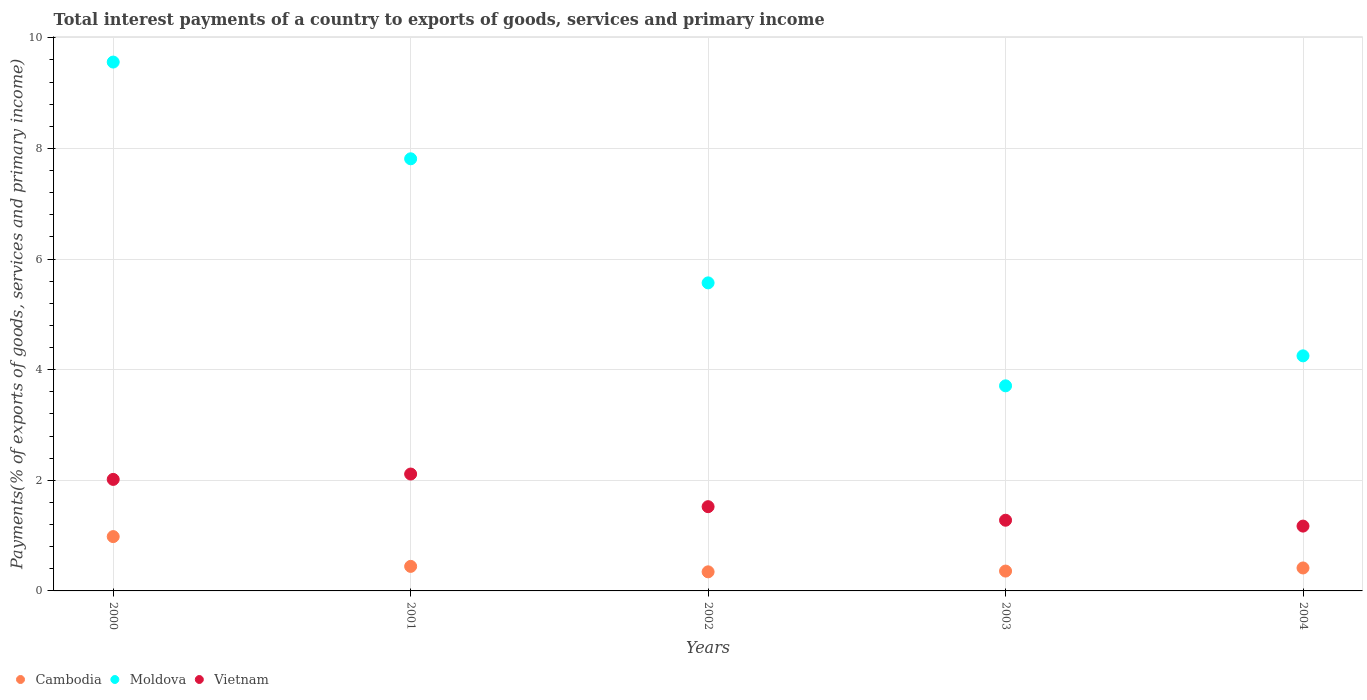What is the total interest payments in Moldova in 2001?
Ensure brevity in your answer.  7.81. Across all years, what is the maximum total interest payments in Cambodia?
Provide a succinct answer. 0.98. Across all years, what is the minimum total interest payments in Moldova?
Provide a short and direct response. 3.71. In which year was the total interest payments in Vietnam maximum?
Provide a short and direct response. 2001. In which year was the total interest payments in Moldova minimum?
Offer a very short reply. 2003. What is the total total interest payments in Vietnam in the graph?
Your answer should be compact. 8.1. What is the difference between the total interest payments in Vietnam in 2003 and that in 2004?
Give a very brief answer. 0.11. What is the difference between the total interest payments in Cambodia in 2002 and the total interest payments in Vietnam in 2001?
Keep it short and to the point. -1.77. What is the average total interest payments in Vietnam per year?
Ensure brevity in your answer.  1.62. In the year 2001, what is the difference between the total interest payments in Moldova and total interest payments in Vietnam?
Your response must be concise. 5.7. In how many years, is the total interest payments in Vietnam greater than 6.8 %?
Your answer should be very brief. 0. What is the ratio of the total interest payments in Cambodia in 2002 to that in 2003?
Offer a terse response. 0.96. What is the difference between the highest and the second highest total interest payments in Vietnam?
Provide a succinct answer. 0.1. What is the difference between the highest and the lowest total interest payments in Vietnam?
Make the answer very short. 0.94. In how many years, is the total interest payments in Moldova greater than the average total interest payments in Moldova taken over all years?
Ensure brevity in your answer.  2. Does the total interest payments in Cambodia monotonically increase over the years?
Your response must be concise. No. Is the total interest payments in Cambodia strictly greater than the total interest payments in Moldova over the years?
Offer a very short reply. No. What is the difference between two consecutive major ticks on the Y-axis?
Offer a very short reply. 2. Are the values on the major ticks of Y-axis written in scientific E-notation?
Ensure brevity in your answer.  No. Does the graph contain any zero values?
Ensure brevity in your answer.  No. Does the graph contain grids?
Provide a short and direct response. Yes. Where does the legend appear in the graph?
Offer a terse response. Bottom left. How many legend labels are there?
Offer a terse response. 3. What is the title of the graph?
Provide a short and direct response. Total interest payments of a country to exports of goods, services and primary income. Does "Thailand" appear as one of the legend labels in the graph?
Offer a terse response. No. What is the label or title of the X-axis?
Ensure brevity in your answer.  Years. What is the label or title of the Y-axis?
Offer a very short reply. Payments(% of exports of goods, services and primary income). What is the Payments(% of exports of goods, services and primary income) of Cambodia in 2000?
Your answer should be compact. 0.98. What is the Payments(% of exports of goods, services and primary income) in Moldova in 2000?
Offer a very short reply. 9.56. What is the Payments(% of exports of goods, services and primary income) in Vietnam in 2000?
Give a very brief answer. 2.02. What is the Payments(% of exports of goods, services and primary income) of Cambodia in 2001?
Provide a short and direct response. 0.44. What is the Payments(% of exports of goods, services and primary income) in Moldova in 2001?
Your answer should be very brief. 7.81. What is the Payments(% of exports of goods, services and primary income) in Vietnam in 2001?
Offer a terse response. 2.11. What is the Payments(% of exports of goods, services and primary income) of Cambodia in 2002?
Provide a short and direct response. 0.35. What is the Payments(% of exports of goods, services and primary income) in Moldova in 2002?
Offer a very short reply. 5.57. What is the Payments(% of exports of goods, services and primary income) in Vietnam in 2002?
Ensure brevity in your answer.  1.52. What is the Payments(% of exports of goods, services and primary income) in Cambodia in 2003?
Give a very brief answer. 0.36. What is the Payments(% of exports of goods, services and primary income) of Moldova in 2003?
Provide a succinct answer. 3.71. What is the Payments(% of exports of goods, services and primary income) in Vietnam in 2003?
Provide a succinct answer. 1.28. What is the Payments(% of exports of goods, services and primary income) in Cambodia in 2004?
Your answer should be very brief. 0.42. What is the Payments(% of exports of goods, services and primary income) of Moldova in 2004?
Your answer should be very brief. 4.25. What is the Payments(% of exports of goods, services and primary income) in Vietnam in 2004?
Your answer should be very brief. 1.17. Across all years, what is the maximum Payments(% of exports of goods, services and primary income) in Cambodia?
Ensure brevity in your answer.  0.98. Across all years, what is the maximum Payments(% of exports of goods, services and primary income) in Moldova?
Provide a short and direct response. 9.56. Across all years, what is the maximum Payments(% of exports of goods, services and primary income) in Vietnam?
Provide a succinct answer. 2.11. Across all years, what is the minimum Payments(% of exports of goods, services and primary income) of Cambodia?
Your answer should be very brief. 0.35. Across all years, what is the minimum Payments(% of exports of goods, services and primary income) in Moldova?
Make the answer very short. 3.71. Across all years, what is the minimum Payments(% of exports of goods, services and primary income) of Vietnam?
Offer a terse response. 1.17. What is the total Payments(% of exports of goods, services and primary income) in Cambodia in the graph?
Your answer should be compact. 2.55. What is the total Payments(% of exports of goods, services and primary income) of Moldova in the graph?
Provide a short and direct response. 30.9. What is the total Payments(% of exports of goods, services and primary income) in Vietnam in the graph?
Make the answer very short. 8.1. What is the difference between the Payments(% of exports of goods, services and primary income) of Cambodia in 2000 and that in 2001?
Provide a short and direct response. 0.54. What is the difference between the Payments(% of exports of goods, services and primary income) of Moldova in 2000 and that in 2001?
Give a very brief answer. 1.75. What is the difference between the Payments(% of exports of goods, services and primary income) of Vietnam in 2000 and that in 2001?
Provide a short and direct response. -0.1. What is the difference between the Payments(% of exports of goods, services and primary income) of Cambodia in 2000 and that in 2002?
Provide a short and direct response. 0.64. What is the difference between the Payments(% of exports of goods, services and primary income) of Moldova in 2000 and that in 2002?
Offer a very short reply. 3.99. What is the difference between the Payments(% of exports of goods, services and primary income) of Vietnam in 2000 and that in 2002?
Your answer should be compact. 0.49. What is the difference between the Payments(% of exports of goods, services and primary income) in Cambodia in 2000 and that in 2003?
Provide a succinct answer. 0.62. What is the difference between the Payments(% of exports of goods, services and primary income) in Moldova in 2000 and that in 2003?
Offer a terse response. 5.85. What is the difference between the Payments(% of exports of goods, services and primary income) in Vietnam in 2000 and that in 2003?
Offer a very short reply. 0.74. What is the difference between the Payments(% of exports of goods, services and primary income) of Cambodia in 2000 and that in 2004?
Offer a terse response. 0.57. What is the difference between the Payments(% of exports of goods, services and primary income) in Moldova in 2000 and that in 2004?
Make the answer very short. 5.31. What is the difference between the Payments(% of exports of goods, services and primary income) of Vietnam in 2000 and that in 2004?
Offer a very short reply. 0.84. What is the difference between the Payments(% of exports of goods, services and primary income) of Cambodia in 2001 and that in 2002?
Make the answer very short. 0.1. What is the difference between the Payments(% of exports of goods, services and primary income) in Moldova in 2001 and that in 2002?
Keep it short and to the point. 2.24. What is the difference between the Payments(% of exports of goods, services and primary income) in Vietnam in 2001 and that in 2002?
Keep it short and to the point. 0.59. What is the difference between the Payments(% of exports of goods, services and primary income) of Cambodia in 2001 and that in 2003?
Provide a succinct answer. 0.08. What is the difference between the Payments(% of exports of goods, services and primary income) of Moldova in 2001 and that in 2003?
Keep it short and to the point. 4.11. What is the difference between the Payments(% of exports of goods, services and primary income) of Vietnam in 2001 and that in 2003?
Your answer should be very brief. 0.84. What is the difference between the Payments(% of exports of goods, services and primary income) of Cambodia in 2001 and that in 2004?
Provide a short and direct response. 0.03. What is the difference between the Payments(% of exports of goods, services and primary income) in Moldova in 2001 and that in 2004?
Your answer should be compact. 3.56. What is the difference between the Payments(% of exports of goods, services and primary income) in Vietnam in 2001 and that in 2004?
Your answer should be very brief. 0.94. What is the difference between the Payments(% of exports of goods, services and primary income) of Cambodia in 2002 and that in 2003?
Offer a terse response. -0.01. What is the difference between the Payments(% of exports of goods, services and primary income) in Moldova in 2002 and that in 2003?
Give a very brief answer. 1.86. What is the difference between the Payments(% of exports of goods, services and primary income) of Vietnam in 2002 and that in 2003?
Offer a terse response. 0.25. What is the difference between the Payments(% of exports of goods, services and primary income) of Cambodia in 2002 and that in 2004?
Make the answer very short. -0.07. What is the difference between the Payments(% of exports of goods, services and primary income) in Moldova in 2002 and that in 2004?
Your response must be concise. 1.32. What is the difference between the Payments(% of exports of goods, services and primary income) of Vietnam in 2002 and that in 2004?
Give a very brief answer. 0.35. What is the difference between the Payments(% of exports of goods, services and primary income) of Cambodia in 2003 and that in 2004?
Make the answer very short. -0.06. What is the difference between the Payments(% of exports of goods, services and primary income) in Moldova in 2003 and that in 2004?
Keep it short and to the point. -0.54. What is the difference between the Payments(% of exports of goods, services and primary income) in Vietnam in 2003 and that in 2004?
Your answer should be compact. 0.11. What is the difference between the Payments(% of exports of goods, services and primary income) in Cambodia in 2000 and the Payments(% of exports of goods, services and primary income) in Moldova in 2001?
Your answer should be very brief. -6.83. What is the difference between the Payments(% of exports of goods, services and primary income) of Cambodia in 2000 and the Payments(% of exports of goods, services and primary income) of Vietnam in 2001?
Offer a terse response. -1.13. What is the difference between the Payments(% of exports of goods, services and primary income) in Moldova in 2000 and the Payments(% of exports of goods, services and primary income) in Vietnam in 2001?
Keep it short and to the point. 7.45. What is the difference between the Payments(% of exports of goods, services and primary income) of Cambodia in 2000 and the Payments(% of exports of goods, services and primary income) of Moldova in 2002?
Make the answer very short. -4.59. What is the difference between the Payments(% of exports of goods, services and primary income) in Cambodia in 2000 and the Payments(% of exports of goods, services and primary income) in Vietnam in 2002?
Make the answer very short. -0.54. What is the difference between the Payments(% of exports of goods, services and primary income) of Moldova in 2000 and the Payments(% of exports of goods, services and primary income) of Vietnam in 2002?
Your response must be concise. 8.04. What is the difference between the Payments(% of exports of goods, services and primary income) in Cambodia in 2000 and the Payments(% of exports of goods, services and primary income) in Moldova in 2003?
Give a very brief answer. -2.73. What is the difference between the Payments(% of exports of goods, services and primary income) of Cambodia in 2000 and the Payments(% of exports of goods, services and primary income) of Vietnam in 2003?
Offer a terse response. -0.3. What is the difference between the Payments(% of exports of goods, services and primary income) of Moldova in 2000 and the Payments(% of exports of goods, services and primary income) of Vietnam in 2003?
Give a very brief answer. 8.28. What is the difference between the Payments(% of exports of goods, services and primary income) in Cambodia in 2000 and the Payments(% of exports of goods, services and primary income) in Moldova in 2004?
Keep it short and to the point. -3.27. What is the difference between the Payments(% of exports of goods, services and primary income) of Cambodia in 2000 and the Payments(% of exports of goods, services and primary income) of Vietnam in 2004?
Ensure brevity in your answer.  -0.19. What is the difference between the Payments(% of exports of goods, services and primary income) of Moldova in 2000 and the Payments(% of exports of goods, services and primary income) of Vietnam in 2004?
Your answer should be very brief. 8.39. What is the difference between the Payments(% of exports of goods, services and primary income) in Cambodia in 2001 and the Payments(% of exports of goods, services and primary income) in Moldova in 2002?
Keep it short and to the point. -5.13. What is the difference between the Payments(% of exports of goods, services and primary income) of Cambodia in 2001 and the Payments(% of exports of goods, services and primary income) of Vietnam in 2002?
Make the answer very short. -1.08. What is the difference between the Payments(% of exports of goods, services and primary income) of Moldova in 2001 and the Payments(% of exports of goods, services and primary income) of Vietnam in 2002?
Offer a very short reply. 6.29. What is the difference between the Payments(% of exports of goods, services and primary income) of Cambodia in 2001 and the Payments(% of exports of goods, services and primary income) of Moldova in 2003?
Offer a terse response. -3.26. What is the difference between the Payments(% of exports of goods, services and primary income) of Cambodia in 2001 and the Payments(% of exports of goods, services and primary income) of Vietnam in 2003?
Ensure brevity in your answer.  -0.83. What is the difference between the Payments(% of exports of goods, services and primary income) of Moldova in 2001 and the Payments(% of exports of goods, services and primary income) of Vietnam in 2003?
Provide a succinct answer. 6.54. What is the difference between the Payments(% of exports of goods, services and primary income) in Cambodia in 2001 and the Payments(% of exports of goods, services and primary income) in Moldova in 2004?
Your response must be concise. -3.81. What is the difference between the Payments(% of exports of goods, services and primary income) of Cambodia in 2001 and the Payments(% of exports of goods, services and primary income) of Vietnam in 2004?
Make the answer very short. -0.73. What is the difference between the Payments(% of exports of goods, services and primary income) in Moldova in 2001 and the Payments(% of exports of goods, services and primary income) in Vietnam in 2004?
Provide a short and direct response. 6.64. What is the difference between the Payments(% of exports of goods, services and primary income) of Cambodia in 2002 and the Payments(% of exports of goods, services and primary income) of Moldova in 2003?
Make the answer very short. -3.36. What is the difference between the Payments(% of exports of goods, services and primary income) of Cambodia in 2002 and the Payments(% of exports of goods, services and primary income) of Vietnam in 2003?
Give a very brief answer. -0.93. What is the difference between the Payments(% of exports of goods, services and primary income) of Moldova in 2002 and the Payments(% of exports of goods, services and primary income) of Vietnam in 2003?
Offer a very short reply. 4.29. What is the difference between the Payments(% of exports of goods, services and primary income) in Cambodia in 2002 and the Payments(% of exports of goods, services and primary income) in Moldova in 2004?
Give a very brief answer. -3.91. What is the difference between the Payments(% of exports of goods, services and primary income) of Cambodia in 2002 and the Payments(% of exports of goods, services and primary income) of Vietnam in 2004?
Your answer should be compact. -0.83. What is the difference between the Payments(% of exports of goods, services and primary income) of Moldova in 2002 and the Payments(% of exports of goods, services and primary income) of Vietnam in 2004?
Offer a very short reply. 4.4. What is the difference between the Payments(% of exports of goods, services and primary income) in Cambodia in 2003 and the Payments(% of exports of goods, services and primary income) in Moldova in 2004?
Give a very brief answer. -3.89. What is the difference between the Payments(% of exports of goods, services and primary income) in Cambodia in 2003 and the Payments(% of exports of goods, services and primary income) in Vietnam in 2004?
Offer a very short reply. -0.81. What is the difference between the Payments(% of exports of goods, services and primary income) of Moldova in 2003 and the Payments(% of exports of goods, services and primary income) of Vietnam in 2004?
Make the answer very short. 2.54. What is the average Payments(% of exports of goods, services and primary income) in Cambodia per year?
Provide a short and direct response. 0.51. What is the average Payments(% of exports of goods, services and primary income) of Moldova per year?
Give a very brief answer. 6.18. What is the average Payments(% of exports of goods, services and primary income) in Vietnam per year?
Offer a very short reply. 1.62. In the year 2000, what is the difference between the Payments(% of exports of goods, services and primary income) in Cambodia and Payments(% of exports of goods, services and primary income) in Moldova?
Your response must be concise. -8.58. In the year 2000, what is the difference between the Payments(% of exports of goods, services and primary income) in Cambodia and Payments(% of exports of goods, services and primary income) in Vietnam?
Your answer should be compact. -1.03. In the year 2000, what is the difference between the Payments(% of exports of goods, services and primary income) of Moldova and Payments(% of exports of goods, services and primary income) of Vietnam?
Offer a terse response. 7.55. In the year 2001, what is the difference between the Payments(% of exports of goods, services and primary income) in Cambodia and Payments(% of exports of goods, services and primary income) in Moldova?
Your answer should be very brief. -7.37. In the year 2001, what is the difference between the Payments(% of exports of goods, services and primary income) in Cambodia and Payments(% of exports of goods, services and primary income) in Vietnam?
Keep it short and to the point. -1.67. In the year 2001, what is the difference between the Payments(% of exports of goods, services and primary income) in Moldova and Payments(% of exports of goods, services and primary income) in Vietnam?
Your answer should be compact. 5.7. In the year 2002, what is the difference between the Payments(% of exports of goods, services and primary income) of Cambodia and Payments(% of exports of goods, services and primary income) of Moldova?
Offer a terse response. -5.22. In the year 2002, what is the difference between the Payments(% of exports of goods, services and primary income) in Cambodia and Payments(% of exports of goods, services and primary income) in Vietnam?
Offer a terse response. -1.18. In the year 2002, what is the difference between the Payments(% of exports of goods, services and primary income) of Moldova and Payments(% of exports of goods, services and primary income) of Vietnam?
Make the answer very short. 4.05. In the year 2003, what is the difference between the Payments(% of exports of goods, services and primary income) in Cambodia and Payments(% of exports of goods, services and primary income) in Moldova?
Ensure brevity in your answer.  -3.35. In the year 2003, what is the difference between the Payments(% of exports of goods, services and primary income) in Cambodia and Payments(% of exports of goods, services and primary income) in Vietnam?
Provide a short and direct response. -0.92. In the year 2003, what is the difference between the Payments(% of exports of goods, services and primary income) of Moldova and Payments(% of exports of goods, services and primary income) of Vietnam?
Your answer should be very brief. 2.43. In the year 2004, what is the difference between the Payments(% of exports of goods, services and primary income) in Cambodia and Payments(% of exports of goods, services and primary income) in Moldova?
Your answer should be very brief. -3.84. In the year 2004, what is the difference between the Payments(% of exports of goods, services and primary income) in Cambodia and Payments(% of exports of goods, services and primary income) in Vietnam?
Offer a very short reply. -0.76. In the year 2004, what is the difference between the Payments(% of exports of goods, services and primary income) of Moldova and Payments(% of exports of goods, services and primary income) of Vietnam?
Make the answer very short. 3.08. What is the ratio of the Payments(% of exports of goods, services and primary income) in Cambodia in 2000 to that in 2001?
Make the answer very short. 2.21. What is the ratio of the Payments(% of exports of goods, services and primary income) in Moldova in 2000 to that in 2001?
Make the answer very short. 1.22. What is the ratio of the Payments(% of exports of goods, services and primary income) in Vietnam in 2000 to that in 2001?
Offer a terse response. 0.95. What is the ratio of the Payments(% of exports of goods, services and primary income) of Cambodia in 2000 to that in 2002?
Your response must be concise. 2.85. What is the ratio of the Payments(% of exports of goods, services and primary income) in Moldova in 2000 to that in 2002?
Ensure brevity in your answer.  1.72. What is the ratio of the Payments(% of exports of goods, services and primary income) in Vietnam in 2000 to that in 2002?
Your response must be concise. 1.32. What is the ratio of the Payments(% of exports of goods, services and primary income) in Cambodia in 2000 to that in 2003?
Your answer should be compact. 2.74. What is the ratio of the Payments(% of exports of goods, services and primary income) in Moldova in 2000 to that in 2003?
Your response must be concise. 2.58. What is the ratio of the Payments(% of exports of goods, services and primary income) of Vietnam in 2000 to that in 2003?
Your response must be concise. 1.58. What is the ratio of the Payments(% of exports of goods, services and primary income) in Cambodia in 2000 to that in 2004?
Ensure brevity in your answer.  2.37. What is the ratio of the Payments(% of exports of goods, services and primary income) in Moldova in 2000 to that in 2004?
Ensure brevity in your answer.  2.25. What is the ratio of the Payments(% of exports of goods, services and primary income) of Vietnam in 2000 to that in 2004?
Offer a very short reply. 1.72. What is the ratio of the Payments(% of exports of goods, services and primary income) of Cambodia in 2001 to that in 2002?
Offer a very short reply. 1.29. What is the ratio of the Payments(% of exports of goods, services and primary income) of Moldova in 2001 to that in 2002?
Your answer should be very brief. 1.4. What is the ratio of the Payments(% of exports of goods, services and primary income) in Vietnam in 2001 to that in 2002?
Your answer should be very brief. 1.39. What is the ratio of the Payments(% of exports of goods, services and primary income) of Cambodia in 2001 to that in 2003?
Provide a succinct answer. 1.24. What is the ratio of the Payments(% of exports of goods, services and primary income) of Moldova in 2001 to that in 2003?
Give a very brief answer. 2.11. What is the ratio of the Payments(% of exports of goods, services and primary income) of Vietnam in 2001 to that in 2003?
Offer a terse response. 1.65. What is the ratio of the Payments(% of exports of goods, services and primary income) in Cambodia in 2001 to that in 2004?
Ensure brevity in your answer.  1.07. What is the ratio of the Payments(% of exports of goods, services and primary income) of Moldova in 2001 to that in 2004?
Offer a terse response. 1.84. What is the ratio of the Payments(% of exports of goods, services and primary income) in Vietnam in 2001 to that in 2004?
Keep it short and to the point. 1.8. What is the ratio of the Payments(% of exports of goods, services and primary income) in Cambodia in 2002 to that in 2003?
Your response must be concise. 0.96. What is the ratio of the Payments(% of exports of goods, services and primary income) in Moldova in 2002 to that in 2003?
Provide a short and direct response. 1.5. What is the ratio of the Payments(% of exports of goods, services and primary income) of Vietnam in 2002 to that in 2003?
Give a very brief answer. 1.19. What is the ratio of the Payments(% of exports of goods, services and primary income) in Cambodia in 2002 to that in 2004?
Offer a very short reply. 0.83. What is the ratio of the Payments(% of exports of goods, services and primary income) in Moldova in 2002 to that in 2004?
Your answer should be very brief. 1.31. What is the ratio of the Payments(% of exports of goods, services and primary income) in Vietnam in 2002 to that in 2004?
Offer a terse response. 1.3. What is the ratio of the Payments(% of exports of goods, services and primary income) in Cambodia in 2003 to that in 2004?
Your answer should be very brief. 0.86. What is the ratio of the Payments(% of exports of goods, services and primary income) of Moldova in 2003 to that in 2004?
Ensure brevity in your answer.  0.87. What is the ratio of the Payments(% of exports of goods, services and primary income) of Vietnam in 2003 to that in 2004?
Provide a short and direct response. 1.09. What is the difference between the highest and the second highest Payments(% of exports of goods, services and primary income) of Cambodia?
Your answer should be very brief. 0.54. What is the difference between the highest and the second highest Payments(% of exports of goods, services and primary income) of Moldova?
Your answer should be very brief. 1.75. What is the difference between the highest and the second highest Payments(% of exports of goods, services and primary income) in Vietnam?
Keep it short and to the point. 0.1. What is the difference between the highest and the lowest Payments(% of exports of goods, services and primary income) of Cambodia?
Your answer should be very brief. 0.64. What is the difference between the highest and the lowest Payments(% of exports of goods, services and primary income) of Moldova?
Provide a short and direct response. 5.85. What is the difference between the highest and the lowest Payments(% of exports of goods, services and primary income) in Vietnam?
Your response must be concise. 0.94. 